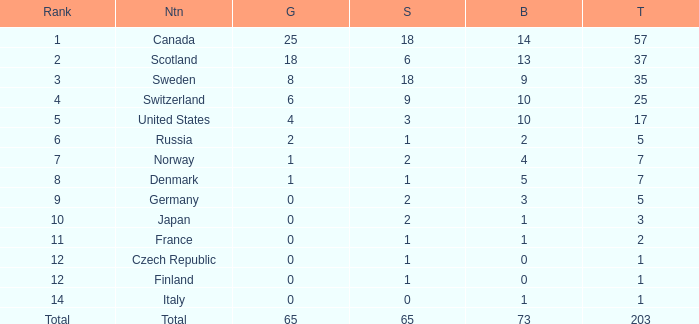What is the lowest total when the rank is 14 and the gold medals is larger than 0? None. Give me the full table as a dictionary. {'header': ['Rank', 'Ntn', 'G', 'S', 'B', 'T'], 'rows': [['1', 'Canada', '25', '18', '14', '57'], ['2', 'Scotland', '18', '6', '13', '37'], ['3', 'Sweden', '8', '18', '9', '35'], ['4', 'Switzerland', '6', '9', '10', '25'], ['5', 'United States', '4', '3', '10', '17'], ['6', 'Russia', '2', '1', '2', '5'], ['7', 'Norway', '1', '2', '4', '7'], ['8', 'Denmark', '1', '1', '5', '7'], ['9', 'Germany', '0', '2', '3', '5'], ['10', 'Japan', '0', '2', '1', '3'], ['11', 'France', '0', '1', '1', '2'], ['12', 'Czech Republic', '0', '1', '0', '1'], ['12', 'Finland', '0', '1', '0', '1'], ['14', 'Italy', '0', '0', '1', '1'], ['Total', 'Total', '65', '65', '73', '203']]} 